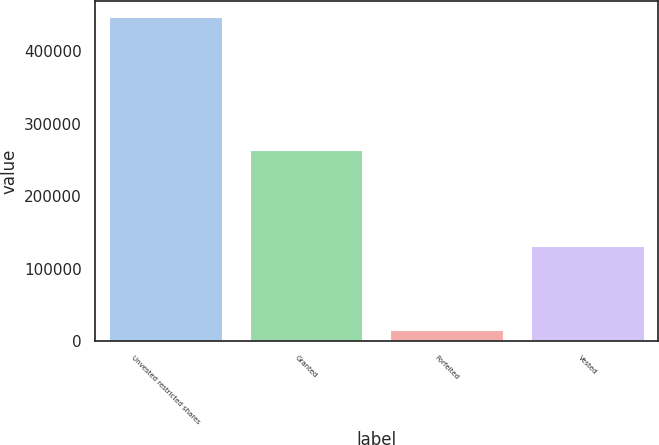Convert chart. <chart><loc_0><loc_0><loc_500><loc_500><bar_chart><fcel>Unvested restricted shares<fcel>Granted<fcel>Forfeited<fcel>Vested<nl><fcel>446978<fcel>263554<fcel>16100<fcel>131254<nl></chart> 